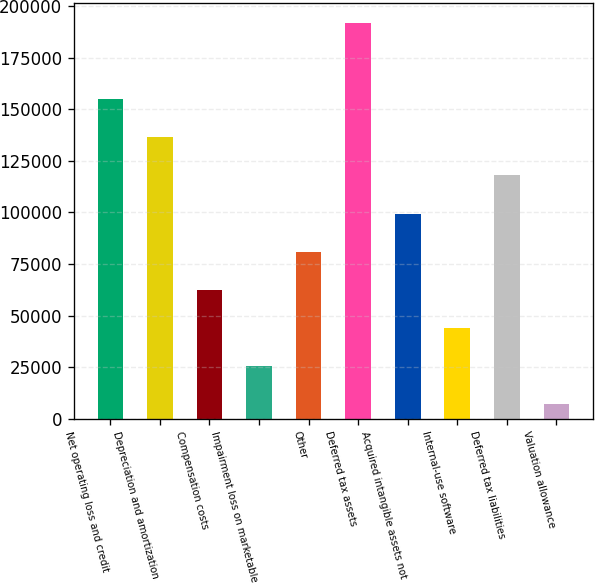Convert chart to OTSL. <chart><loc_0><loc_0><loc_500><loc_500><bar_chart><fcel>Net operating loss and credit<fcel>Depreciation and amortization<fcel>Compensation costs<fcel>Impairment loss on marketable<fcel>Other<fcel>Deferred tax assets<fcel>Acquired intangible assets not<fcel>Internal-use software<fcel>Deferred tax liabilities<fcel>Valuation allowance<nl><fcel>154966<fcel>136481<fcel>62541<fcel>25571<fcel>81026<fcel>191936<fcel>99511<fcel>44056<fcel>117996<fcel>7086<nl></chart> 